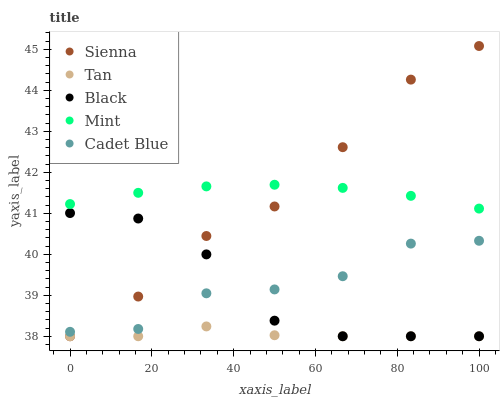Does Tan have the minimum area under the curve?
Answer yes or no. Yes. Does Mint have the maximum area under the curve?
Answer yes or no. Yes. Does Mint have the minimum area under the curve?
Answer yes or no. No. Does Tan have the maximum area under the curve?
Answer yes or no. No. Is Mint the smoothest?
Answer yes or no. Yes. Is Black the roughest?
Answer yes or no. Yes. Is Tan the smoothest?
Answer yes or no. No. Is Tan the roughest?
Answer yes or no. No. Does Sienna have the lowest value?
Answer yes or no. Yes. Does Mint have the lowest value?
Answer yes or no. No. Does Sienna have the highest value?
Answer yes or no. Yes. Does Mint have the highest value?
Answer yes or no. No. Is Cadet Blue less than Mint?
Answer yes or no. Yes. Is Mint greater than Black?
Answer yes or no. Yes. Does Cadet Blue intersect Black?
Answer yes or no. Yes. Is Cadet Blue less than Black?
Answer yes or no. No. Is Cadet Blue greater than Black?
Answer yes or no. No. Does Cadet Blue intersect Mint?
Answer yes or no. No. 